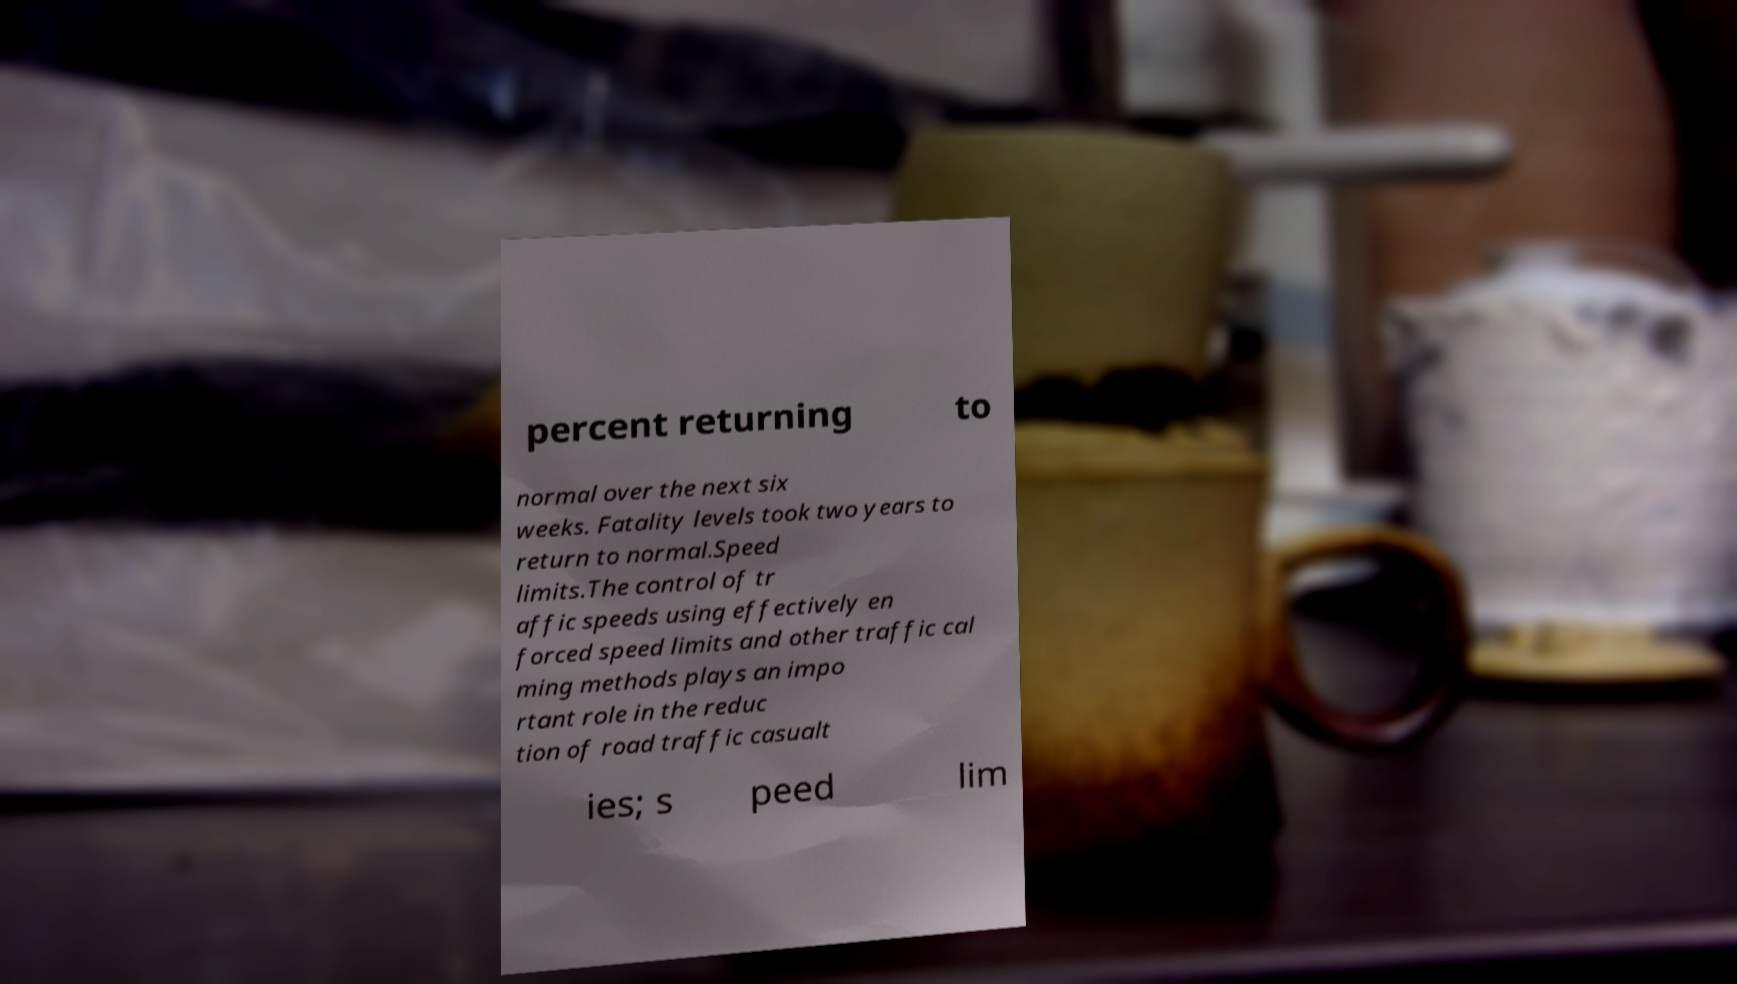There's text embedded in this image that I need extracted. Can you transcribe it verbatim? percent returning to normal over the next six weeks. Fatality levels took two years to return to normal.Speed limits.The control of tr affic speeds using effectively en forced speed limits and other traffic cal ming methods plays an impo rtant role in the reduc tion of road traffic casualt ies; s peed lim 